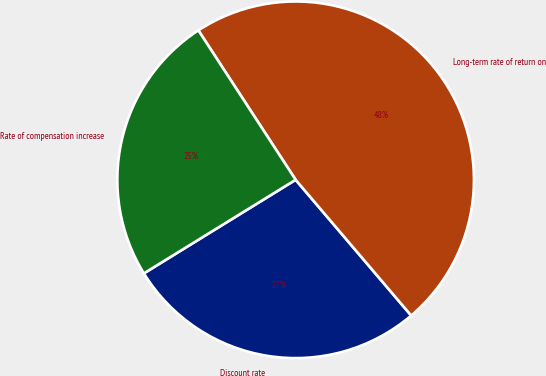<chart> <loc_0><loc_0><loc_500><loc_500><pie_chart><fcel>Discount rate<fcel>Long-term rate of return on<fcel>Rate of compensation increase<nl><fcel>27.43%<fcel>47.96%<fcel>24.61%<nl></chart> 